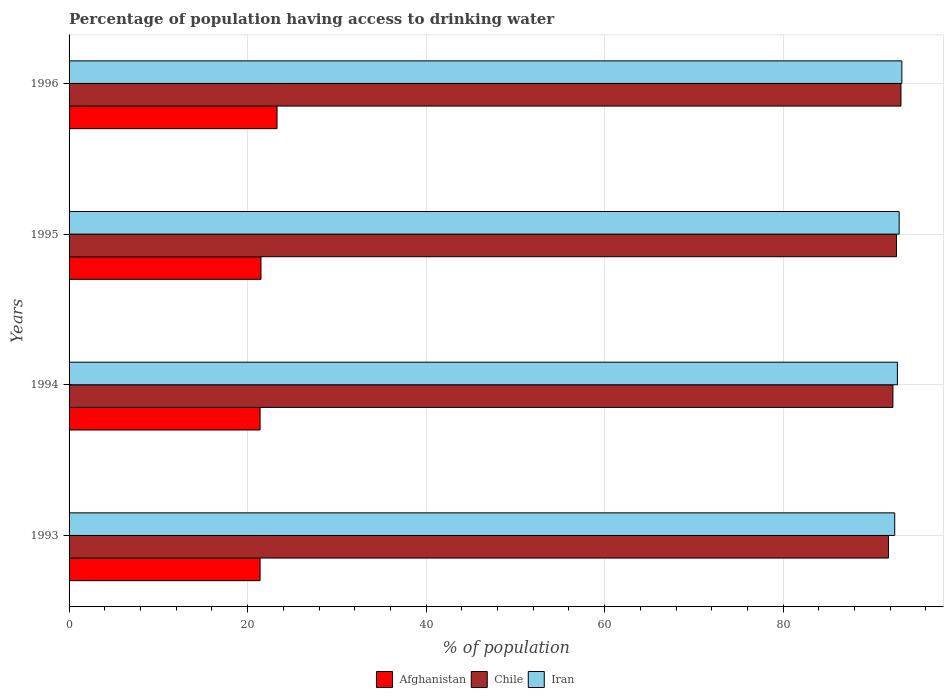How many groups of bars are there?
Your response must be concise. 4. In how many cases, is the number of bars for a given year not equal to the number of legend labels?
Provide a succinct answer. 0. What is the percentage of population having access to drinking water in Iran in 1996?
Your answer should be compact. 93.3. Across all years, what is the maximum percentage of population having access to drinking water in Afghanistan?
Offer a very short reply. 23.3. Across all years, what is the minimum percentage of population having access to drinking water in Iran?
Give a very brief answer. 92.5. In which year was the percentage of population having access to drinking water in Iran maximum?
Keep it short and to the point. 1996. What is the total percentage of population having access to drinking water in Afghanistan in the graph?
Your answer should be compact. 87.6. What is the difference between the percentage of population having access to drinking water in Chile in 1994 and that in 1996?
Provide a short and direct response. -0.9. What is the difference between the percentage of population having access to drinking water in Iran in 1996 and the percentage of population having access to drinking water in Afghanistan in 1995?
Offer a terse response. 71.8. What is the average percentage of population having access to drinking water in Iran per year?
Provide a succinct answer. 92.9. In the year 1996, what is the difference between the percentage of population having access to drinking water in Chile and percentage of population having access to drinking water in Afghanistan?
Ensure brevity in your answer.  69.9. In how many years, is the percentage of population having access to drinking water in Chile greater than 68 %?
Your answer should be compact. 4. What is the ratio of the percentage of population having access to drinking water in Chile in 1993 to that in 1996?
Give a very brief answer. 0.98. Is the percentage of population having access to drinking water in Chile in 1994 less than that in 1995?
Provide a succinct answer. Yes. What is the difference between the highest and the second highest percentage of population having access to drinking water in Iran?
Offer a very short reply. 0.3. What is the difference between the highest and the lowest percentage of population having access to drinking water in Afghanistan?
Provide a short and direct response. 1.9. In how many years, is the percentage of population having access to drinking water in Afghanistan greater than the average percentage of population having access to drinking water in Afghanistan taken over all years?
Make the answer very short. 1. Is the sum of the percentage of population having access to drinking water in Afghanistan in 1995 and 1996 greater than the maximum percentage of population having access to drinking water in Chile across all years?
Provide a succinct answer. No. What does the 1st bar from the top in 1995 represents?
Your answer should be compact. Iran. Is it the case that in every year, the sum of the percentage of population having access to drinking water in Chile and percentage of population having access to drinking water in Iran is greater than the percentage of population having access to drinking water in Afghanistan?
Your answer should be very brief. Yes. How many bars are there?
Make the answer very short. 12. How many years are there in the graph?
Your response must be concise. 4. Does the graph contain any zero values?
Offer a very short reply. No. How many legend labels are there?
Ensure brevity in your answer.  3. How are the legend labels stacked?
Give a very brief answer. Horizontal. What is the title of the graph?
Your answer should be compact. Percentage of population having access to drinking water. What is the label or title of the X-axis?
Provide a short and direct response. % of population. What is the % of population of Afghanistan in 1993?
Keep it short and to the point. 21.4. What is the % of population of Chile in 1993?
Your answer should be very brief. 91.8. What is the % of population of Iran in 1993?
Keep it short and to the point. 92.5. What is the % of population in Afghanistan in 1994?
Give a very brief answer. 21.4. What is the % of population of Chile in 1994?
Offer a very short reply. 92.3. What is the % of population in Iran in 1994?
Give a very brief answer. 92.8. What is the % of population in Afghanistan in 1995?
Give a very brief answer. 21.5. What is the % of population of Chile in 1995?
Make the answer very short. 92.7. What is the % of population in Iran in 1995?
Make the answer very short. 93. What is the % of population in Afghanistan in 1996?
Offer a terse response. 23.3. What is the % of population of Chile in 1996?
Offer a very short reply. 93.2. What is the % of population in Iran in 1996?
Make the answer very short. 93.3. Across all years, what is the maximum % of population in Afghanistan?
Your response must be concise. 23.3. Across all years, what is the maximum % of population in Chile?
Offer a very short reply. 93.2. Across all years, what is the maximum % of population in Iran?
Your response must be concise. 93.3. Across all years, what is the minimum % of population in Afghanistan?
Give a very brief answer. 21.4. Across all years, what is the minimum % of population in Chile?
Offer a terse response. 91.8. Across all years, what is the minimum % of population of Iran?
Offer a terse response. 92.5. What is the total % of population of Afghanistan in the graph?
Offer a terse response. 87.6. What is the total % of population of Chile in the graph?
Make the answer very short. 370. What is the total % of population in Iran in the graph?
Keep it short and to the point. 371.6. What is the difference between the % of population of Afghanistan in 1993 and that in 1994?
Make the answer very short. 0. What is the difference between the % of population in Chile in 1993 and that in 1995?
Your response must be concise. -0.9. What is the difference between the % of population of Iran in 1993 and that in 1996?
Give a very brief answer. -0.8. What is the difference between the % of population of Iran in 1994 and that in 1995?
Offer a very short reply. -0.2. What is the difference between the % of population in Afghanistan in 1994 and that in 1996?
Ensure brevity in your answer.  -1.9. What is the difference between the % of population of Chile in 1994 and that in 1996?
Provide a succinct answer. -0.9. What is the difference between the % of population of Iran in 1995 and that in 1996?
Offer a very short reply. -0.3. What is the difference between the % of population in Afghanistan in 1993 and the % of population in Chile in 1994?
Offer a very short reply. -70.9. What is the difference between the % of population of Afghanistan in 1993 and the % of population of Iran in 1994?
Keep it short and to the point. -71.4. What is the difference between the % of population of Chile in 1993 and the % of population of Iran in 1994?
Your answer should be compact. -1. What is the difference between the % of population in Afghanistan in 1993 and the % of population in Chile in 1995?
Give a very brief answer. -71.3. What is the difference between the % of population of Afghanistan in 1993 and the % of population of Iran in 1995?
Your answer should be very brief. -71.6. What is the difference between the % of population in Afghanistan in 1993 and the % of population in Chile in 1996?
Offer a terse response. -71.8. What is the difference between the % of population in Afghanistan in 1993 and the % of population in Iran in 1996?
Make the answer very short. -71.9. What is the difference between the % of population of Chile in 1993 and the % of population of Iran in 1996?
Ensure brevity in your answer.  -1.5. What is the difference between the % of population in Afghanistan in 1994 and the % of population in Chile in 1995?
Keep it short and to the point. -71.3. What is the difference between the % of population of Afghanistan in 1994 and the % of population of Iran in 1995?
Ensure brevity in your answer.  -71.6. What is the difference between the % of population of Afghanistan in 1994 and the % of population of Chile in 1996?
Your answer should be compact. -71.8. What is the difference between the % of population in Afghanistan in 1994 and the % of population in Iran in 1996?
Offer a very short reply. -71.9. What is the difference between the % of population of Chile in 1994 and the % of population of Iran in 1996?
Your response must be concise. -1. What is the difference between the % of population in Afghanistan in 1995 and the % of population in Chile in 1996?
Ensure brevity in your answer.  -71.7. What is the difference between the % of population in Afghanistan in 1995 and the % of population in Iran in 1996?
Your answer should be compact. -71.8. What is the difference between the % of population of Chile in 1995 and the % of population of Iran in 1996?
Offer a very short reply. -0.6. What is the average % of population of Afghanistan per year?
Give a very brief answer. 21.9. What is the average % of population in Chile per year?
Offer a very short reply. 92.5. What is the average % of population of Iran per year?
Provide a short and direct response. 92.9. In the year 1993, what is the difference between the % of population in Afghanistan and % of population in Chile?
Keep it short and to the point. -70.4. In the year 1993, what is the difference between the % of population in Afghanistan and % of population in Iran?
Give a very brief answer. -71.1. In the year 1994, what is the difference between the % of population of Afghanistan and % of population of Chile?
Offer a very short reply. -70.9. In the year 1994, what is the difference between the % of population in Afghanistan and % of population in Iran?
Your answer should be compact. -71.4. In the year 1994, what is the difference between the % of population of Chile and % of population of Iran?
Your answer should be compact. -0.5. In the year 1995, what is the difference between the % of population in Afghanistan and % of population in Chile?
Provide a succinct answer. -71.2. In the year 1995, what is the difference between the % of population in Afghanistan and % of population in Iran?
Provide a succinct answer. -71.5. In the year 1995, what is the difference between the % of population of Chile and % of population of Iran?
Give a very brief answer. -0.3. In the year 1996, what is the difference between the % of population in Afghanistan and % of population in Chile?
Your response must be concise. -69.9. In the year 1996, what is the difference between the % of population in Afghanistan and % of population in Iran?
Provide a short and direct response. -70. In the year 1996, what is the difference between the % of population in Chile and % of population in Iran?
Offer a very short reply. -0.1. What is the ratio of the % of population in Afghanistan in 1993 to that in 1994?
Give a very brief answer. 1. What is the ratio of the % of population in Afghanistan in 1993 to that in 1995?
Provide a succinct answer. 1. What is the ratio of the % of population of Chile in 1993 to that in 1995?
Keep it short and to the point. 0.99. What is the ratio of the % of population in Iran in 1993 to that in 1995?
Keep it short and to the point. 0.99. What is the ratio of the % of population in Afghanistan in 1993 to that in 1996?
Give a very brief answer. 0.92. What is the ratio of the % of population of Iran in 1993 to that in 1996?
Your answer should be very brief. 0.99. What is the ratio of the % of population in Afghanistan in 1994 to that in 1995?
Provide a succinct answer. 1. What is the ratio of the % of population in Afghanistan in 1994 to that in 1996?
Offer a terse response. 0.92. What is the ratio of the % of population in Chile in 1994 to that in 1996?
Your response must be concise. 0.99. What is the ratio of the % of population of Afghanistan in 1995 to that in 1996?
Your answer should be compact. 0.92. What is the ratio of the % of population in Iran in 1995 to that in 1996?
Ensure brevity in your answer.  1. What is the difference between the highest and the second highest % of population in Iran?
Provide a short and direct response. 0.3. What is the difference between the highest and the lowest % of population in Afghanistan?
Make the answer very short. 1.9. 